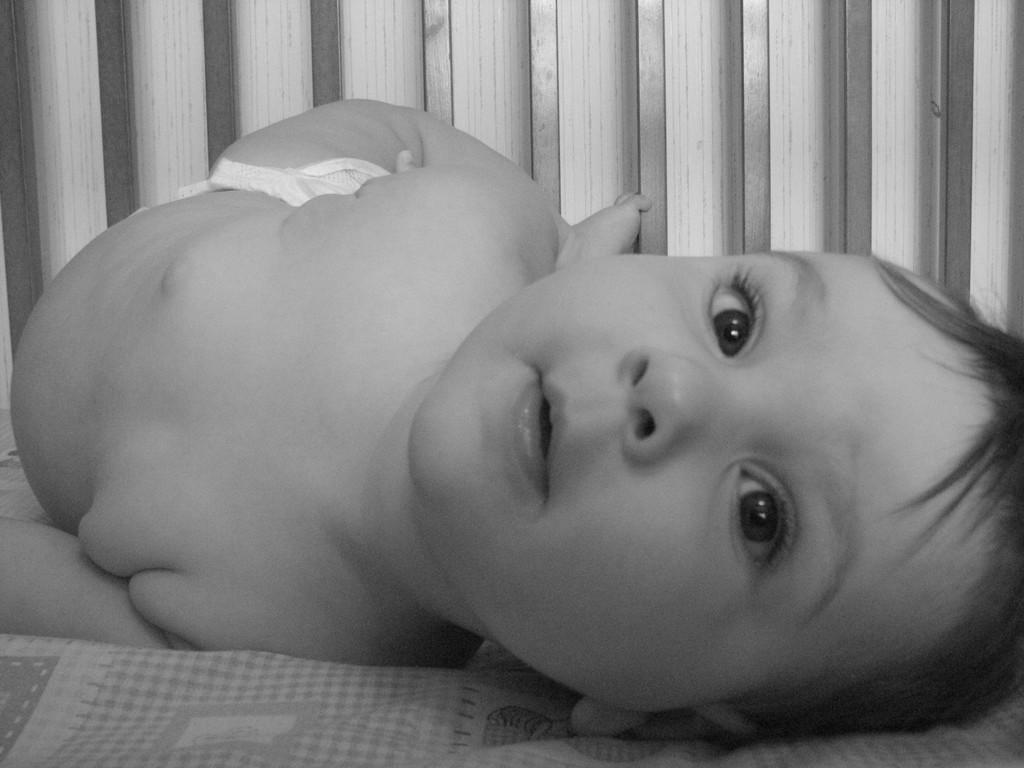What is the color scheme of the image? The image is black and white. What is the kid doing in the image? The kid is lying on a cloth in the image. What can be seen in the background of the image? There is a platform visible in the background of the image. What type of plate is being used by the kid in the image? There is no plate visible in the image; the kid is lying on a cloth. Can you see a quiver in the image? There is no quiver present in the image. 